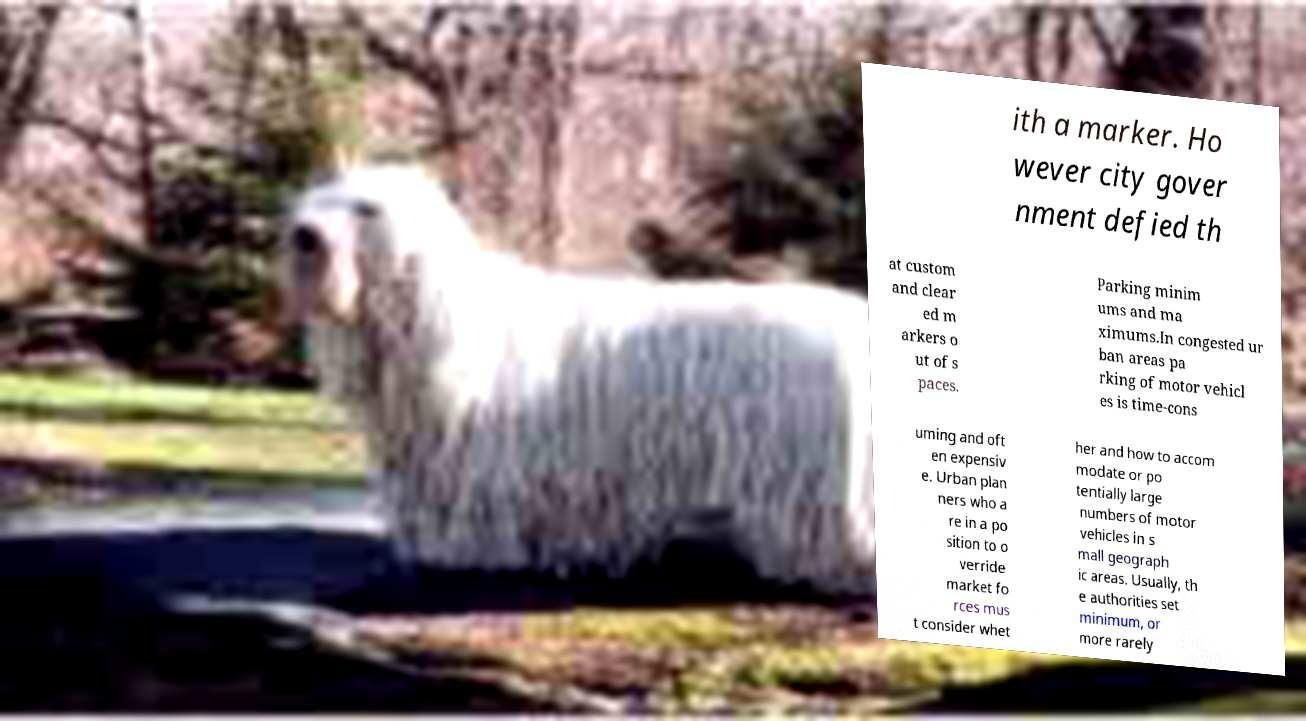There's text embedded in this image that I need extracted. Can you transcribe it verbatim? ith a marker. Ho wever city gover nment defied th at custom and clear ed m arkers o ut of s paces. Parking minim ums and ma ximums.In congested ur ban areas pa rking of motor vehicl es is time-cons uming and oft en expensiv e. Urban plan ners who a re in a po sition to o verride market fo rces mus t consider whet her and how to accom modate or po tentially large numbers of motor vehicles in s mall geograph ic areas. Usually, th e authorities set minimum, or more rarely 